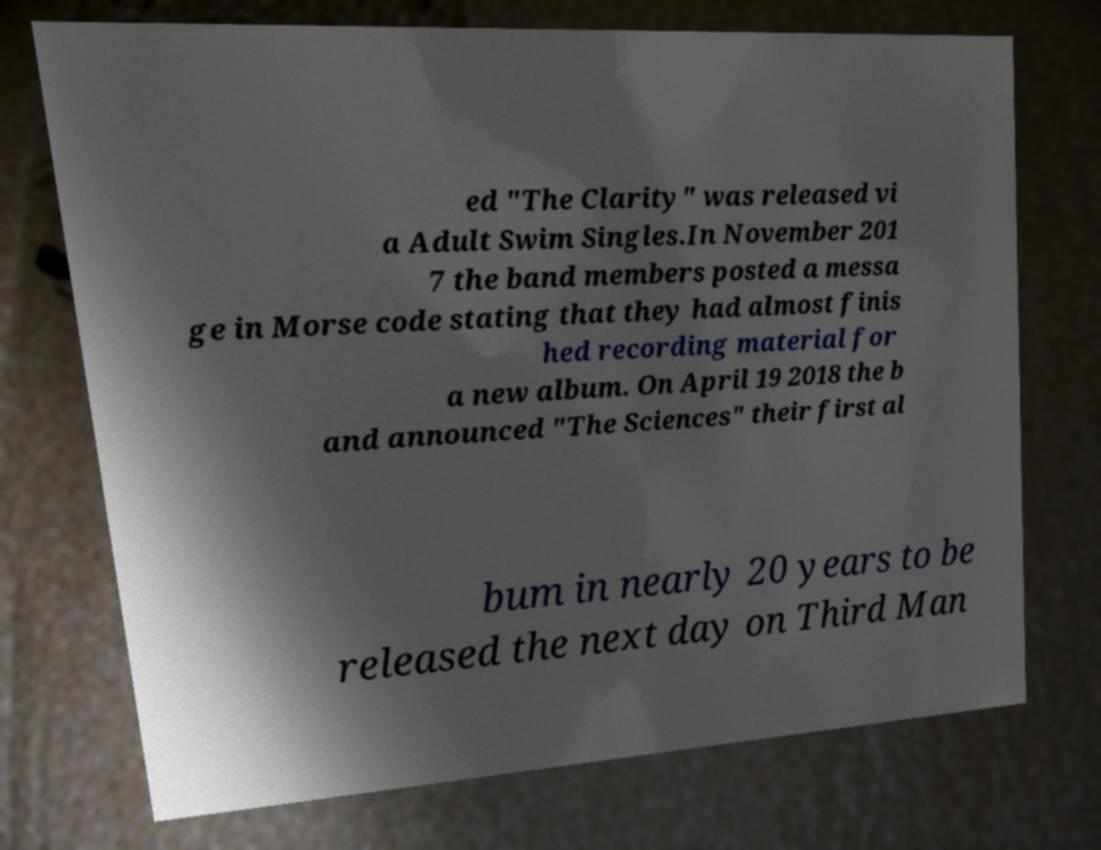Please read and relay the text visible in this image. What does it say? ed "The Clarity" was released vi a Adult Swim Singles.In November 201 7 the band members posted a messa ge in Morse code stating that they had almost finis hed recording material for a new album. On April 19 2018 the b and announced "The Sciences" their first al bum in nearly 20 years to be released the next day on Third Man 